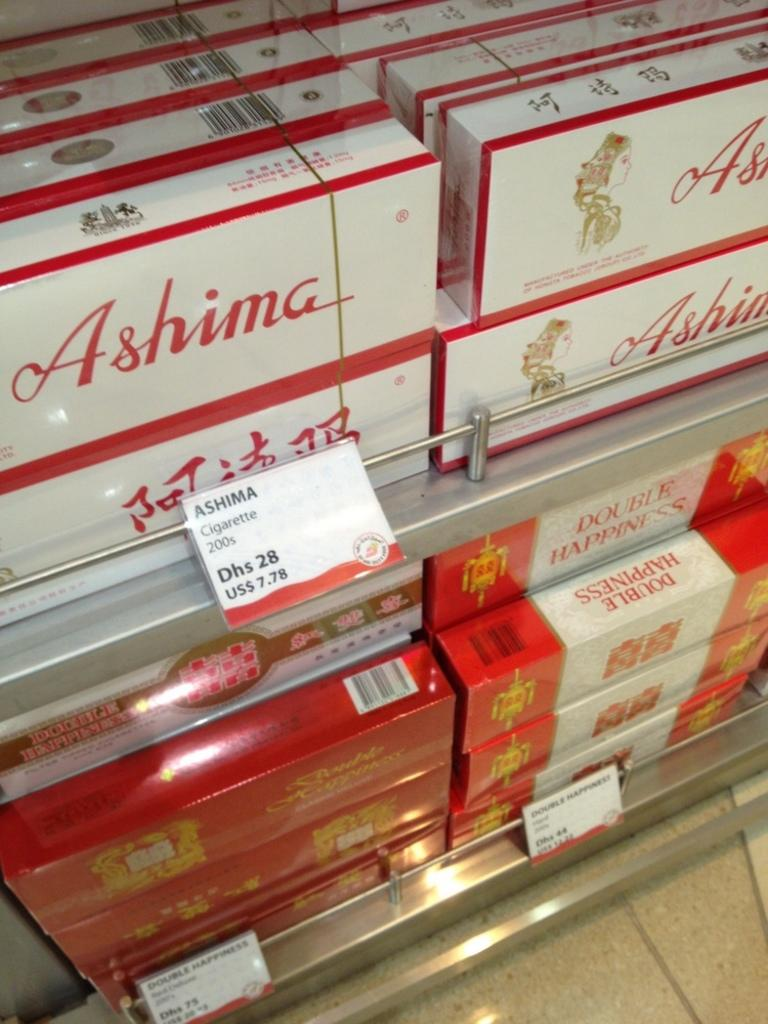<image>
Describe the image concisely. Several cartons of Ashima are for sale in a store. 